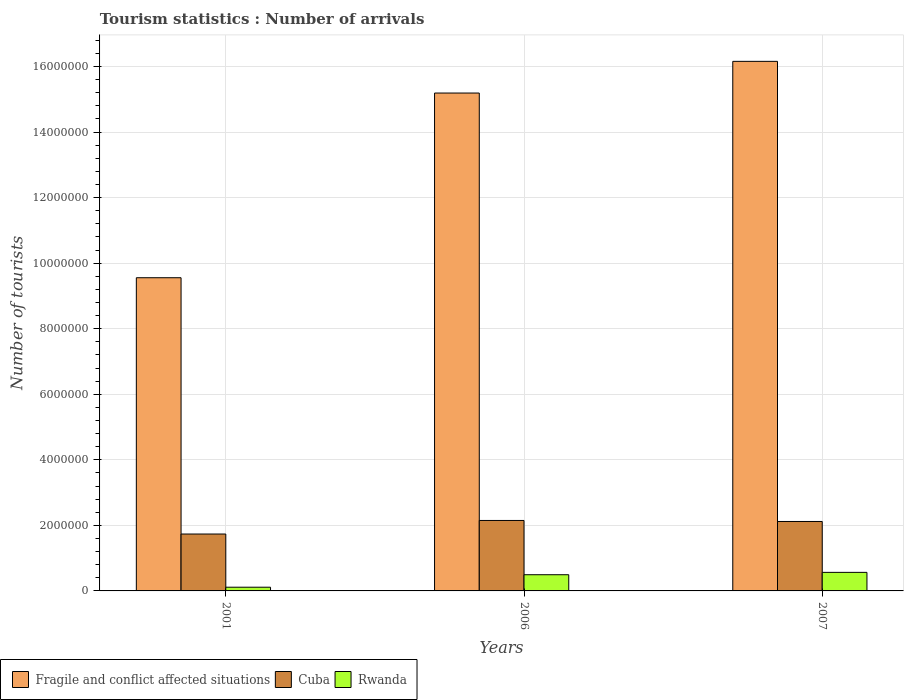How many different coloured bars are there?
Ensure brevity in your answer.  3. How many groups of bars are there?
Offer a very short reply. 3. In how many cases, is the number of bars for a given year not equal to the number of legend labels?
Offer a terse response. 0. What is the number of tourist arrivals in Rwanda in 2007?
Give a very brief answer. 5.66e+05. Across all years, what is the maximum number of tourist arrivals in Cuba?
Give a very brief answer. 2.15e+06. Across all years, what is the minimum number of tourist arrivals in Cuba?
Offer a very short reply. 1.74e+06. What is the total number of tourist arrivals in Fragile and conflict affected situations in the graph?
Your answer should be very brief. 4.09e+07. What is the difference between the number of tourist arrivals in Rwanda in 2001 and that in 2006?
Provide a succinct answer. -3.81e+05. What is the difference between the number of tourist arrivals in Fragile and conflict affected situations in 2007 and the number of tourist arrivals in Rwanda in 2006?
Provide a short and direct response. 1.57e+07. What is the average number of tourist arrivals in Fragile and conflict affected situations per year?
Give a very brief answer. 1.36e+07. In the year 2007, what is the difference between the number of tourist arrivals in Fragile and conflict affected situations and number of tourist arrivals in Cuba?
Ensure brevity in your answer.  1.40e+07. What is the ratio of the number of tourist arrivals in Rwanda in 2001 to that in 2007?
Your answer should be compact. 0.2. What is the difference between the highest and the second highest number of tourist arrivals in Rwanda?
Your response must be concise. 7.20e+04. What is the difference between the highest and the lowest number of tourist arrivals in Fragile and conflict affected situations?
Give a very brief answer. 6.60e+06. In how many years, is the number of tourist arrivals in Rwanda greater than the average number of tourist arrivals in Rwanda taken over all years?
Keep it short and to the point. 2. Is the sum of the number of tourist arrivals in Fragile and conflict affected situations in 2006 and 2007 greater than the maximum number of tourist arrivals in Rwanda across all years?
Offer a terse response. Yes. What does the 1st bar from the left in 2007 represents?
Give a very brief answer. Fragile and conflict affected situations. What does the 3rd bar from the right in 2007 represents?
Your answer should be compact. Fragile and conflict affected situations. What is the difference between two consecutive major ticks on the Y-axis?
Make the answer very short. 2.00e+06. Does the graph contain grids?
Your answer should be very brief. Yes. Where does the legend appear in the graph?
Your answer should be very brief. Bottom left. How many legend labels are there?
Keep it short and to the point. 3. How are the legend labels stacked?
Your answer should be very brief. Horizontal. What is the title of the graph?
Your answer should be very brief. Tourism statistics : Number of arrivals. What is the label or title of the Y-axis?
Your response must be concise. Number of tourists. What is the Number of tourists of Fragile and conflict affected situations in 2001?
Provide a succinct answer. 9.56e+06. What is the Number of tourists in Cuba in 2001?
Offer a very short reply. 1.74e+06. What is the Number of tourists in Rwanda in 2001?
Provide a succinct answer. 1.13e+05. What is the Number of tourists in Fragile and conflict affected situations in 2006?
Your answer should be compact. 1.52e+07. What is the Number of tourists in Cuba in 2006?
Offer a very short reply. 2.15e+06. What is the Number of tourists of Rwanda in 2006?
Make the answer very short. 4.94e+05. What is the Number of tourists in Fragile and conflict affected situations in 2007?
Make the answer very short. 1.62e+07. What is the Number of tourists in Cuba in 2007?
Your response must be concise. 2.12e+06. What is the Number of tourists of Rwanda in 2007?
Your response must be concise. 5.66e+05. Across all years, what is the maximum Number of tourists in Fragile and conflict affected situations?
Provide a succinct answer. 1.62e+07. Across all years, what is the maximum Number of tourists of Cuba?
Provide a succinct answer. 2.15e+06. Across all years, what is the maximum Number of tourists in Rwanda?
Keep it short and to the point. 5.66e+05. Across all years, what is the minimum Number of tourists of Fragile and conflict affected situations?
Your response must be concise. 9.56e+06. Across all years, what is the minimum Number of tourists of Cuba?
Provide a succinct answer. 1.74e+06. Across all years, what is the minimum Number of tourists of Rwanda?
Your answer should be compact. 1.13e+05. What is the total Number of tourists in Fragile and conflict affected situations in the graph?
Your response must be concise. 4.09e+07. What is the total Number of tourists in Cuba in the graph?
Keep it short and to the point. 6.00e+06. What is the total Number of tourists of Rwanda in the graph?
Ensure brevity in your answer.  1.17e+06. What is the difference between the Number of tourists of Fragile and conflict affected situations in 2001 and that in 2006?
Ensure brevity in your answer.  -5.64e+06. What is the difference between the Number of tourists of Cuba in 2001 and that in 2006?
Provide a succinct answer. -4.14e+05. What is the difference between the Number of tourists in Rwanda in 2001 and that in 2006?
Your response must be concise. -3.81e+05. What is the difference between the Number of tourists in Fragile and conflict affected situations in 2001 and that in 2007?
Ensure brevity in your answer.  -6.60e+06. What is the difference between the Number of tourists in Cuba in 2001 and that in 2007?
Offer a terse response. -3.83e+05. What is the difference between the Number of tourists in Rwanda in 2001 and that in 2007?
Make the answer very short. -4.53e+05. What is the difference between the Number of tourists in Fragile and conflict affected situations in 2006 and that in 2007?
Provide a succinct answer. -9.67e+05. What is the difference between the Number of tourists of Cuba in 2006 and that in 2007?
Offer a terse response. 3.10e+04. What is the difference between the Number of tourists in Rwanda in 2006 and that in 2007?
Your answer should be compact. -7.20e+04. What is the difference between the Number of tourists of Fragile and conflict affected situations in 2001 and the Number of tourists of Cuba in 2006?
Your answer should be very brief. 7.41e+06. What is the difference between the Number of tourists in Fragile and conflict affected situations in 2001 and the Number of tourists in Rwanda in 2006?
Give a very brief answer. 9.06e+06. What is the difference between the Number of tourists in Cuba in 2001 and the Number of tourists in Rwanda in 2006?
Your answer should be very brief. 1.24e+06. What is the difference between the Number of tourists of Fragile and conflict affected situations in 2001 and the Number of tourists of Cuba in 2007?
Give a very brief answer. 7.44e+06. What is the difference between the Number of tourists of Fragile and conflict affected situations in 2001 and the Number of tourists of Rwanda in 2007?
Keep it short and to the point. 8.99e+06. What is the difference between the Number of tourists in Cuba in 2001 and the Number of tourists in Rwanda in 2007?
Give a very brief answer. 1.17e+06. What is the difference between the Number of tourists of Fragile and conflict affected situations in 2006 and the Number of tourists of Cuba in 2007?
Your response must be concise. 1.31e+07. What is the difference between the Number of tourists in Fragile and conflict affected situations in 2006 and the Number of tourists in Rwanda in 2007?
Your answer should be compact. 1.46e+07. What is the difference between the Number of tourists of Cuba in 2006 and the Number of tourists of Rwanda in 2007?
Make the answer very short. 1.58e+06. What is the average Number of tourists in Fragile and conflict affected situations per year?
Your answer should be compact. 1.36e+07. What is the average Number of tourists in Cuba per year?
Keep it short and to the point. 2.00e+06. What is the average Number of tourists of Rwanda per year?
Your answer should be very brief. 3.91e+05. In the year 2001, what is the difference between the Number of tourists in Fragile and conflict affected situations and Number of tourists in Cuba?
Keep it short and to the point. 7.82e+06. In the year 2001, what is the difference between the Number of tourists in Fragile and conflict affected situations and Number of tourists in Rwanda?
Your answer should be compact. 9.44e+06. In the year 2001, what is the difference between the Number of tourists in Cuba and Number of tourists in Rwanda?
Give a very brief answer. 1.62e+06. In the year 2006, what is the difference between the Number of tourists in Fragile and conflict affected situations and Number of tourists in Cuba?
Give a very brief answer. 1.30e+07. In the year 2006, what is the difference between the Number of tourists of Fragile and conflict affected situations and Number of tourists of Rwanda?
Ensure brevity in your answer.  1.47e+07. In the year 2006, what is the difference between the Number of tourists of Cuba and Number of tourists of Rwanda?
Your answer should be very brief. 1.66e+06. In the year 2007, what is the difference between the Number of tourists in Fragile and conflict affected situations and Number of tourists in Cuba?
Keep it short and to the point. 1.40e+07. In the year 2007, what is the difference between the Number of tourists of Fragile and conflict affected situations and Number of tourists of Rwanda?
Provide a succinct answer. 1.56e+07. In the year 2007, what is the difference between the Number of tourists of Cuba and Number of tourists of Rwanda?
Keep it short and to the point. 1.55e+06. What is the ratio of the Number of tourists in Fragile and conflict affected situations in 2001 to that in 2006?
Provide a succinct answer. 0.63. What is the ratio of the Number of tourists of Cuba in 2001 to that in 2006?
Ensure brevity in your answer.  0.81. What is the ratio of the Number of tourists of Rwanda in 2001 to that in 2006?
Give a very brief answer. 0.23. What is the ratio of the Number of tourists in Fragile and conflict affected situations in 2001 to that in 2007?
Keep it short and to the point. 0.59. What is the ratio of the Number of tourists in Cuba in 2001 to that in 2007?
Your answer should be compact. 0.82. What is the ratio of the Number of tourists of Rwanda in 2001 to that in 2007?
Offer a very short reply. 0.2. What is the ratio of the Number of tourists of Fragile and conflict affected situations in 2006 to that in 2007?
Offer a terse response. 0.94. What is the ratio of the Number of tourists in Cuba in 2006 to that in 2007?
Give a very brief answer. 1.01. What is the ratio of the Number of tourists of Rwanda in 2006 to that in 2007?
Your answer should be very brief. 0.87. What is the difference between the highest and the second highest Number of tourists in Fragile and conflict affected situations?
Your response must be concise. 9.67e+05. What is the difference between the highest and the second highest Number of tourists in Cuba?
Ensure brevity in your answer.  3.10e+04. What is the difference between the highest and the second highest Number of tourists of Rwanda?
Offer a very short reply. 7.20e+04. What is the difference between the highest and the lowest Number of tourists in Fragile and conflict affected situations?
Give a very brief answer. 6.60e+06. What is the difference between the highest and the lowest Number of tourists in Cuba?
Your answer should be compact. 4.14e+05. What is the difference between the highest and the lowest Number of tourists of Rwanda?
Provide a succinct answer. 4.53e+05. 